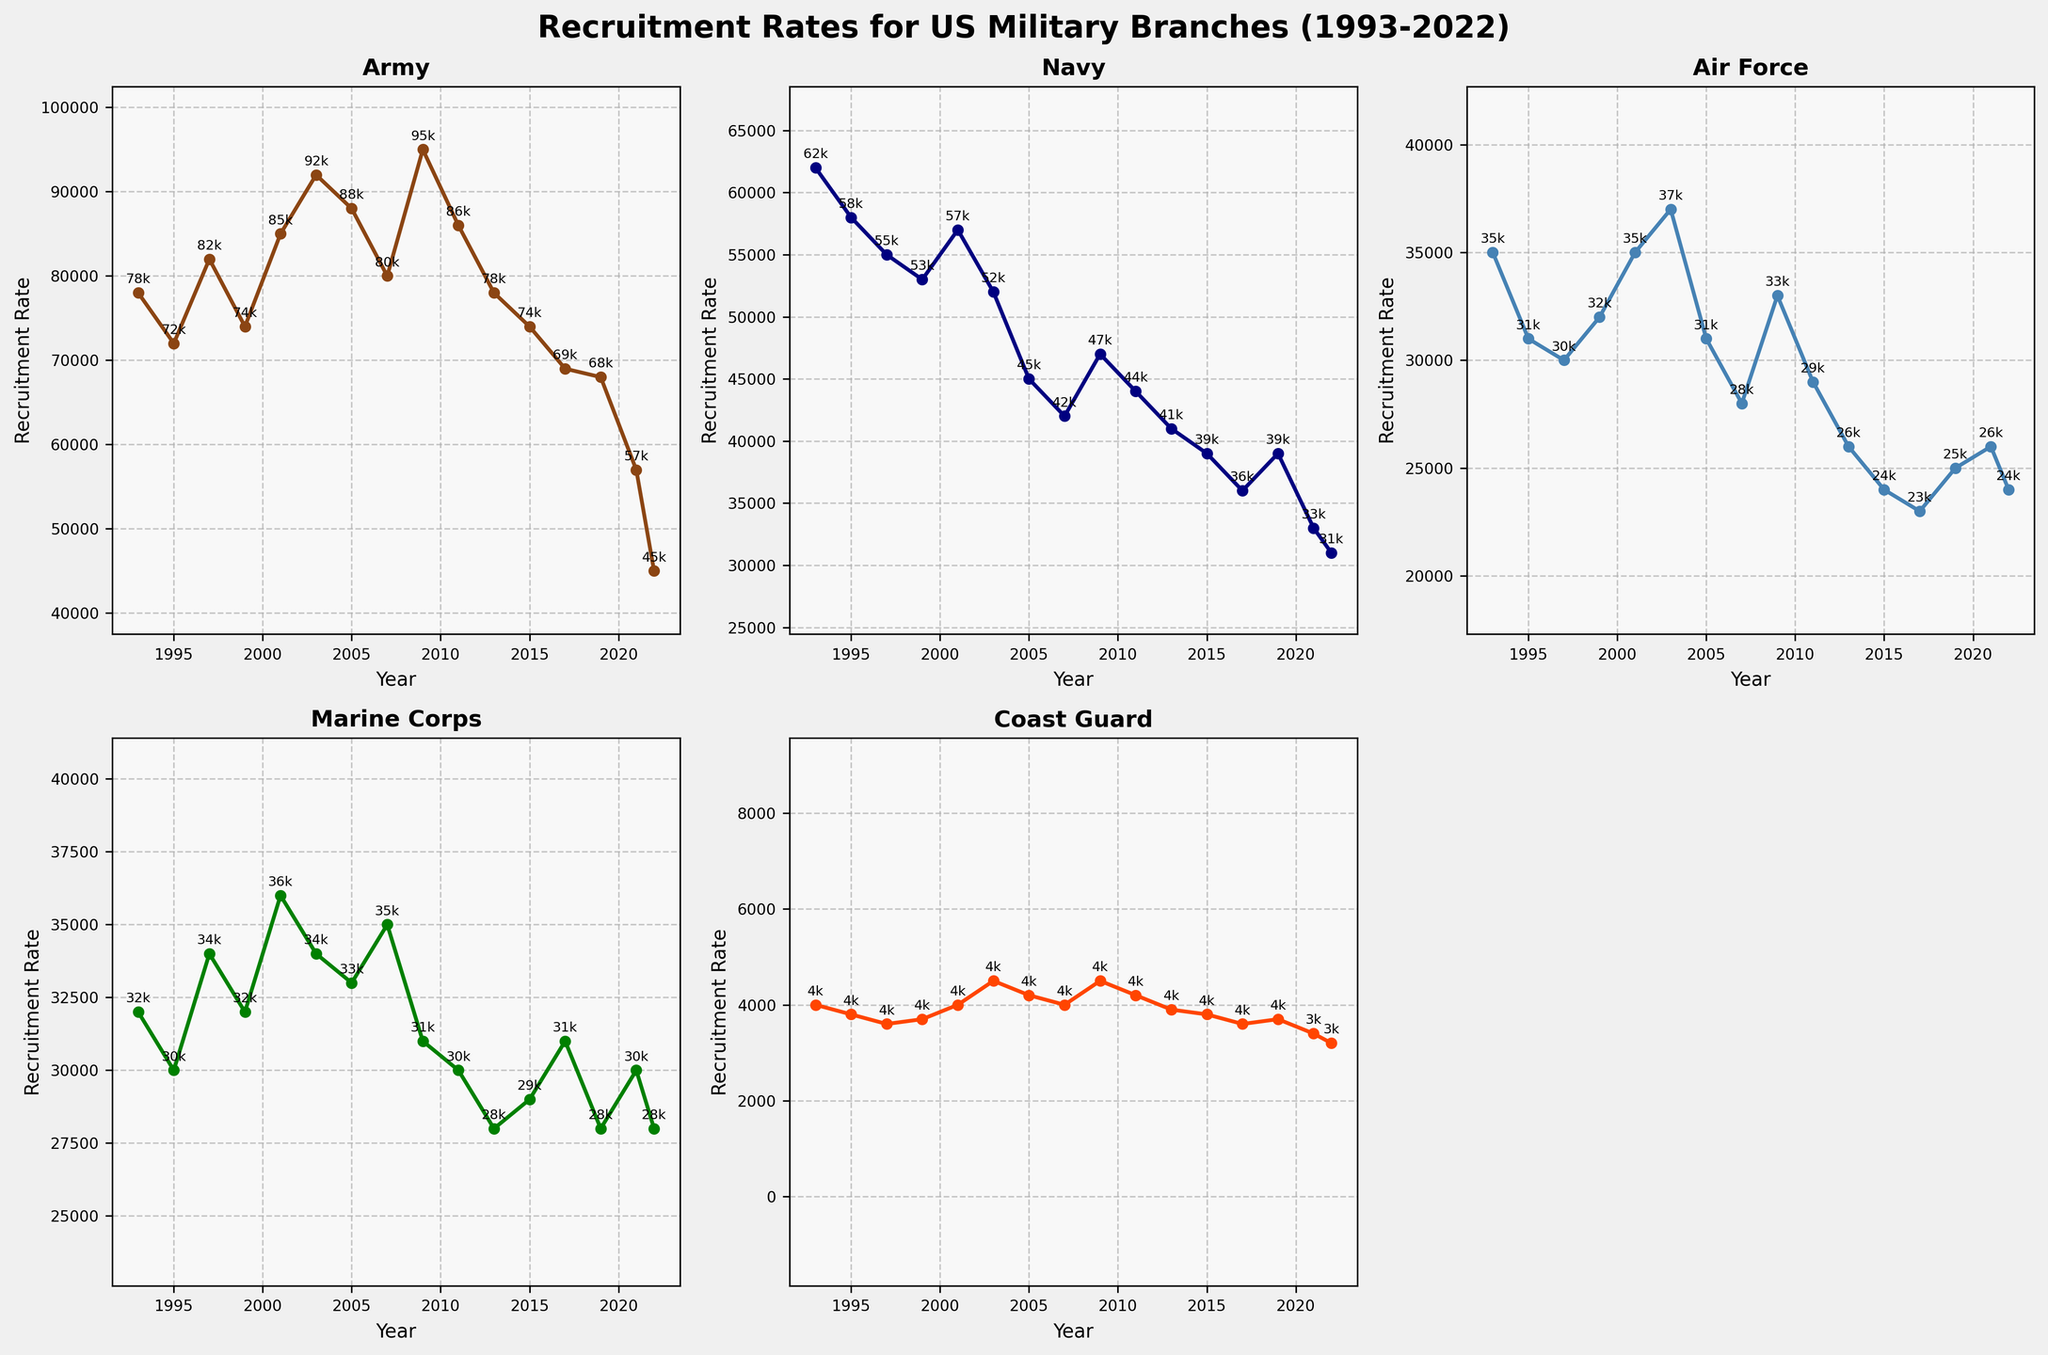Which military branch had the highest recruitment rate in 2009? Look at the line chart for each branch in 2009. The Army's recruitment rate is highest compared to others.
Answer: Army From 1993 to 2022, which branch showed the most variability in recruitment rates? Examine the fluctuation in the recruitment lines for all branches over the years. The Army shows the greatest changes in recruitment rates.
Answer: Army What is the combined recruitment rate for the Marine Corps and the Air Force in 2021? Locate the recruitment rates for both Marine Corps and Air Force in 2021, then sum these numbers: 30000 (Marine Corps) + 26000 (Air Force) = 56000.
Answer: 56000 Was there any year where the Coast Guard's recruitment rate was higher than the Air Force's? Check if the Coast Guard's line ever goes above the Air Force's line. Throughout the timeframe, the Coast Guard's recruitment rate always remains below the Air Force's rate.
Answer: No Which branch witnessed a continuous decline in recruitment rates from 1999 to 2005? Follow the trend lines between 1999 and 2005. The Navy shows a continuous decrease in its recruitment rates during this period.
Answer: Navy How did the Army's recruitment rate change from 2019 to 2022? Note the Army's recruitment rates in 2019 and 2022. The rate decreased from 68000 in 2019 to 45000 in 2022, a significant decline.
Answer: Decreased Between the Air Force and Marine Corps, which branch had higher recruitment rates more frequently between 1993 and 2022? Compare the lines of the Air Force and Marine Corps over the years. The Air Force had higher recruitment rates for most of the years in this period.
Answer: Air Force Determine the average recruitment rate for the Coast Guard from 2015 to 2022. Sum the recruitment rates for the Coast Guard from 2015 to 2022 and divide by the number of years: (3800 + 3600 + 3700 + 3400 + 3200) / 5 = 3540.
Answer: 3540 Compare the recruitment rates of the Navy in 1995 and 2005. How much did it change? Extract the values for the Navy in 1995 (58000) and 2005 (45000). The difference is 58000 - 45000 = 13000.
Answer: Decreased by 13000 